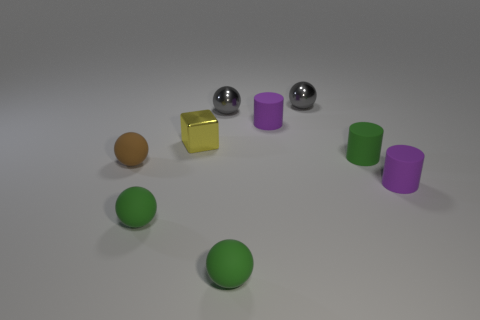Subtract all small green spheres. How many spheres are left? 3 Subtract all green cylinders. How many cylinders are left? 2 Add 1 small brown cubes. How many objects exist? 10 Subtract 2 purple cylinders. How many objects are left? 7 Subtract all blocks. How many objects are left? 8 Subtract 2 cylinders. How many cylinders are left? 1 Subtract all green cylinders. Subtract all red blocks. How many cylinders are left? 2 Subtract all brown blocks. How many green cylinders are left? 1 Subtract all small yellow metallic objects. Subtract all yellow things. How many objects are left? 7 Add 1 tiny brown matte spheres. How many tiny brown matte spheres are left? 2 